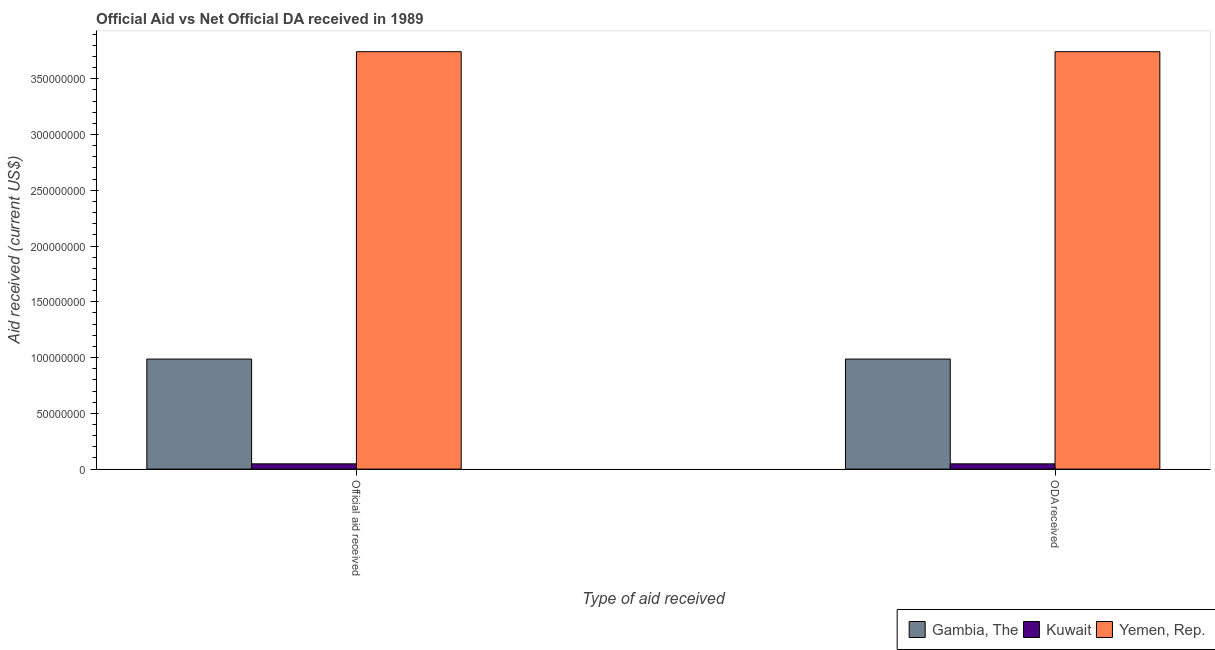How many different coloured bars are there?
Make the answer very short. 3. How many groups of bars are there?
Provide a succinct answer. 2. Are the number of bars per tick equal to the number of legend labels?
Offer a terse response. Yes. What is the label of the 1st group of bars from the left?
Make the answer very short. Official aid received. What is the official aid received in Yemen, Rep.?
Provide a succinct answer. 3.74e+08. Across all countries, what is the maximum oda received?
Offer a very short reply. 3.74e+08. Across all countries, what is the minimum official aid received?
Offer a very short reply. 4.72e+06. In which country was the official aid received maximum?
Give a very brief answer. Yemen, Rep. In which country was the oda received minimum?
Give a very brief answer. Kuwait. What is the total official aid received in the graph?
Provide a succinct answer. 4.78e+08. What is the difference between the official aid received in Yemen, Rep. and that in Gambia, The?
Keep it short and to the point. 2.76e+08. What is the difference between the oda received in Kuwait and the official aid received in Gambia, The?
Give a very brief answer. -9.39e+07. What is the average oda received per country?
Ensure brevity in your answer.  1.59e+08. What is the difference between the official aid received and oda received in Yemen, Rep.?
Your response must be concise. 0. What is the ratio of the oda received in Yemen, Rep. to that in Kuwait?
Your answer should be very brief. 79.3. What does the 2nd bar from the left in ODA received represents?
Make the answer very short. Kuwait. What does the 2nd bar from the right in Official aid received represents?
Provide a short and direct response. Kuwait. How many bars are there?
Offer a very short reply. 6. Are all the bars in the graph horizontal?
Your answer should be very brief. No. What is the difference between two consecutive major ticks on the Y-axis?
Offer a terse response. 5.00e+07. Are the values on the major ticks of Y-axis written in scientific E-notation?
Your answer should be very brief. No. Where does the legend appear in the graph?
Your answer should be compact. Bottom right. How are the legend labels stacked?
Provide a succinct answer. Horizontal. What is the title of the graph?
Provide a succinct answer. Official Aid vs Net Official DA received in 1989 . What is the label or title of the X-axis?
Provide a short and direct response. Type of aid received. What is the label or title of the Y-axis?
Provide a short and direct response. Aid received (current US$). What is the Aid received (current US$) in Gambia, The in Official aid received?
Offer a very short reply. 9.87e+07. What is the Aid received (current US$) of Kuwait in Official aid received?
Give a very brief answer. 4.72e+06. What is the Aid received (current US$) of Yemen, Rep. in Official aid received?
Your answer should be compact. 3.74e+08. What is the Aid received (current US$) in Gambia, The in ODA received?
Offer a terse response. 9.87e+07. What is the Aid received (current US$) in Kuwait in ODA received?
Give a very brief answer. 4.72e+06. What is the Aid received (current US$) of Yemen, Rep. in ODA received?
Offer a terse response. 3.74e+08. Across all Type of aid received, what is the maximum Aid received (current US$) of Gambia, The?
Offer a terse response. 9.87e+07. Across all Type of aid received, what is the maximum Aid received (current US$) in Kuwait?
Offer a very short reply. 4.72e+06. Across all Type of aid received, what is the maximum Aid received (current US$) in Yemen, Rep.?
Make the answer very short. 3.74e+08. Across all Type of aid received, what is the minimum Aid received (current US$) in Gambia, The?
Offer a very short reply. 9.87e+07. Across all Type of aid received, what is the minimum Aid received (current US$) in Kuwait?
Keep it short and to the point. 4.72e+06. Across all Type of aid received, what is the minimum Aid received (current US$) of Yemen, Rep.?
Keep it short and to the point. 3.74e+08. What is the total Aid received (current US$) of Gambia, The in the graph?
Offer a very short reply. 1.97e+08. What is the total Aid received (current US$) of Kuwait in the graph?
Your answer should be very brief. 9.44e+06. What is the total Aid received (current US$) of Yemen, Rep. in the graph?
Give a very brief answer. 7.49e+08. What is the difference between the Aid received (current US$) of Gambia, The in Official aid received and that in ODA received?
Offer a very short reply. 0. What is the difference between the Aid received (current US$) in Kuwait in Official aid received and that in ODA received?
Provide a succinct answer. 0. What is the difference between the Aid received (current US$) of Yemen, Rep. in Official aid received and that in ODA received?
Your answer should be compact. 0. What is the difference between the Aid received (current US$) in Gambia, The in Official aid received and the Aid received (current US$) in Kuwait in ODA received?
Give a very brief answer. 9.39e+07. What is the difference between the Aid received (current US$) of Gambia, The in Official aid received and the Aid received (current US$) of Yemen, Rep. in ODA received?
Provide a short and direct response. -2.76e+08. What is the difference between the Aid received (current US$) of Kuwait in Official aid received and the Aid received (current US$) of Yemen, Rep. in ODA received?
Your response must be concise. -3.70e+08. What is the average Aid received (current US$) in Gambia, The per Type of aid received?
Offer a very short reply. 9.87e+07. What is the average Aid received (current US$) of Kuwait per Type of aid received?
Ensure brevity in your answer.  4.72e+06. What is the average Aid received (current US$) of Yemen, Rep. per Type of aid received?
Keep it short and to the point. 3.74e+08. What is the difference between the Aid received (current US$) of Gambia, The and Aid received (current US$) of Kuwait in Official aid received?
Your answer should be compact. 9.39e+07. What is the difference between the Aid received (current US$) in Gambia, The and Aid received (current US$) in Yemen, Rep. in Official aid received?
Provide a short and direct response. -2.76e+08. What is the difference between the Aid received (current US$) in Kuwait and Aid received (current US$) in Yemen, Rep. in Official aid received?
Ensure brevity in your answer.  -3.70e+08. What is the difference between the Aid received (current US$) of Gambia, The and Aid received (current US$) of Kuwait in ODA received?
Offer a very short reply. 9.39e+07. What is the difference between the Aid received (current US$) of Gambia, The and Aid received (current US$) of Yemen, Rep. in ODA received?
Offer a very short reply. -2.76e+08. What is the difference between the Aid received (current US$) of Kuwait and Aid received (current US$) of Yemen, Rep. in ODA received?
Provide a succinct answer. -3.70e+08. What is the difference between the highest and the second highest Aid received (current US$) of Gambia, The?
Your answer should be very brief. 0. What is the difference between the highest and the lowest Aid received (current US$) in Gambia, The?
Keep it short and to the point. 0. 